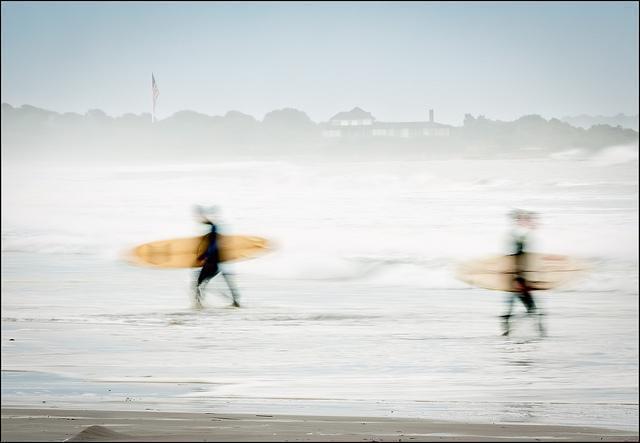How many blurry figures are passing the ocean with a surfboard in their hands?
From the following four choices, select the correct answer to address the question.
Options: Three, four, two, one. Two. 